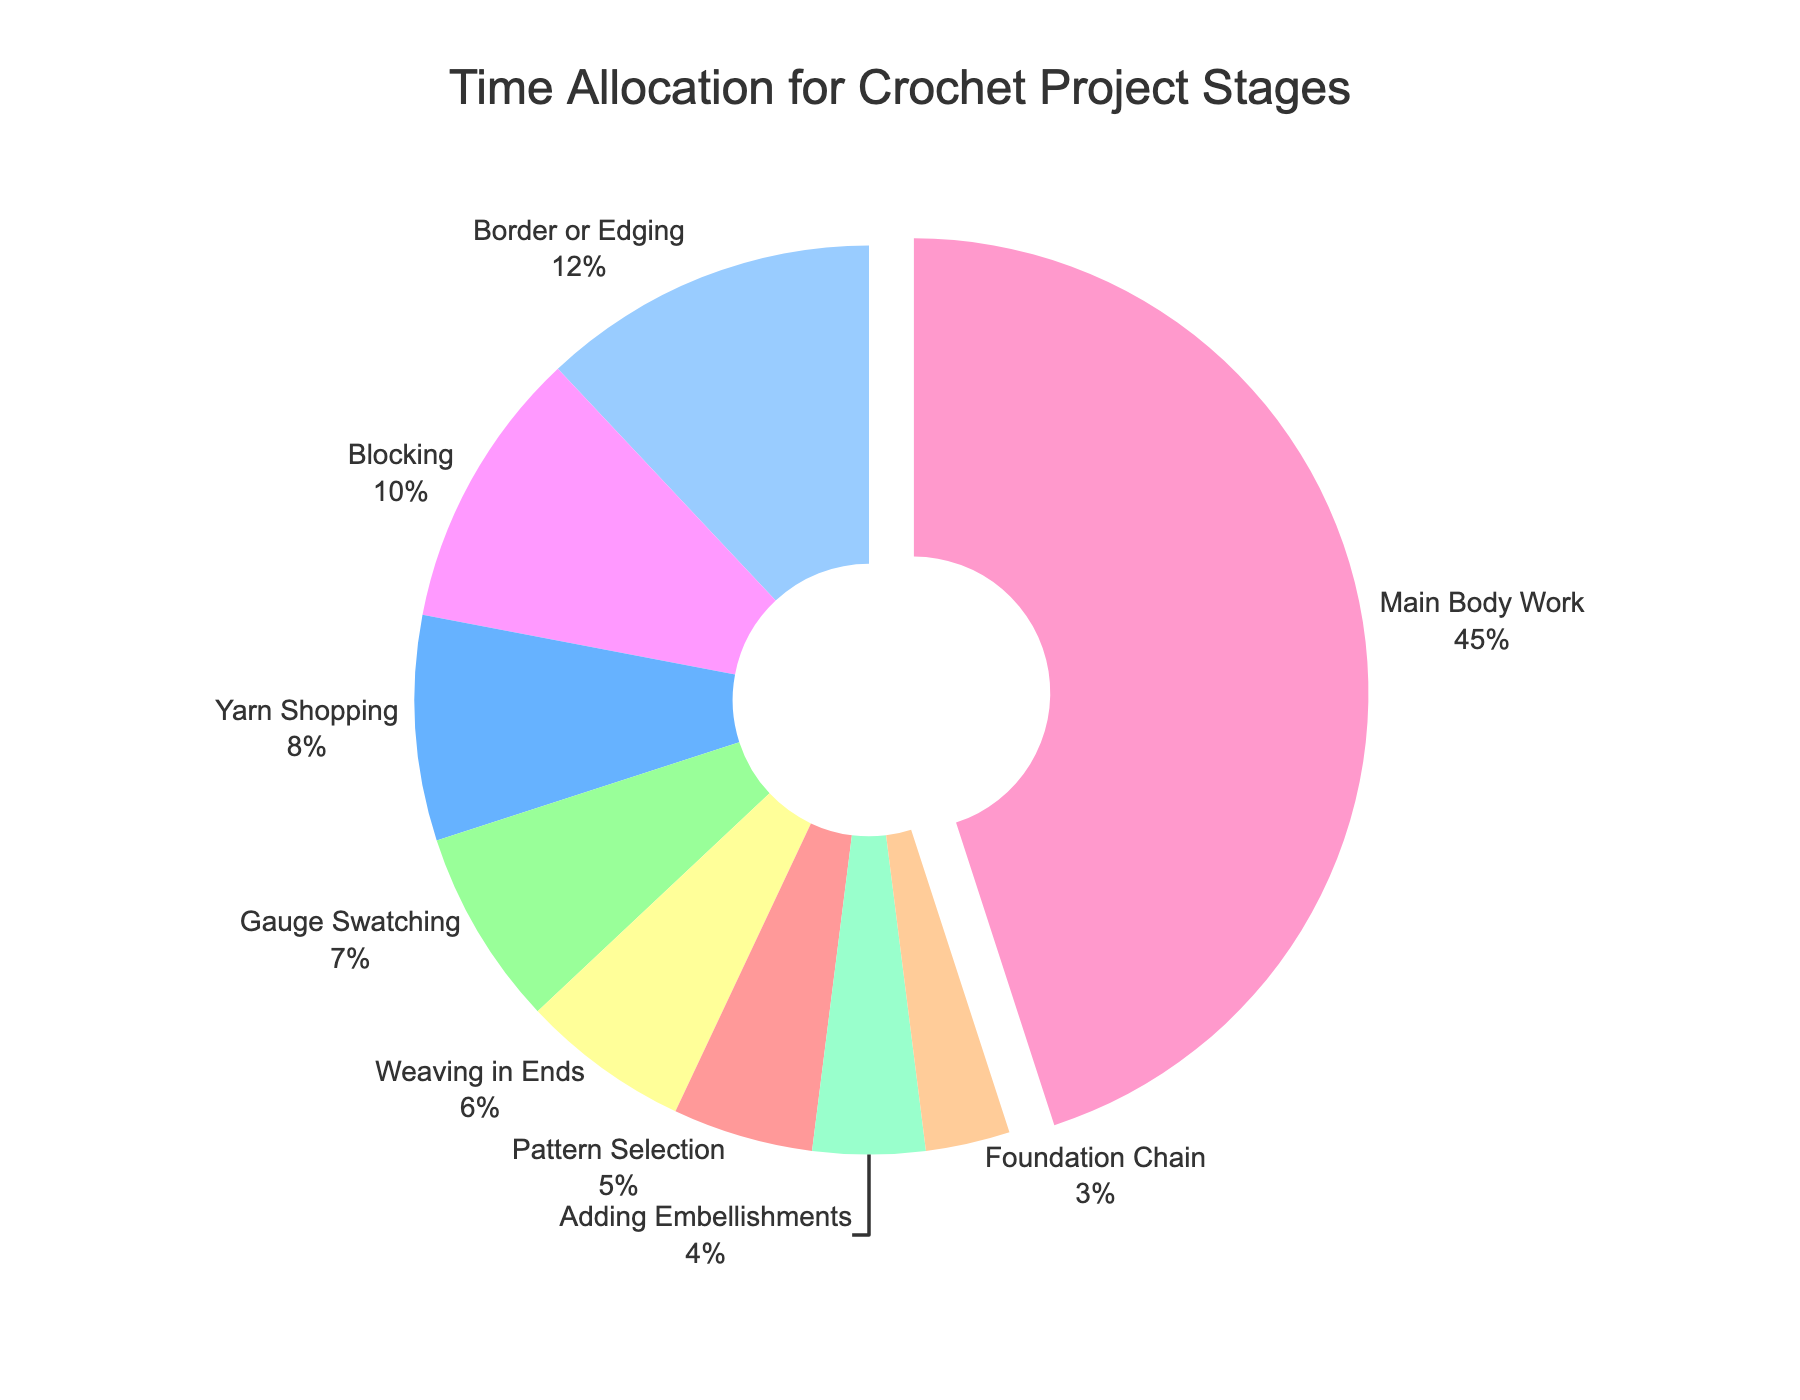What stage takes the most time in the crochet project? The section with the largest percentage is the "Main Body Work," which is visually pulled out from the pie due to the hole configuration. Its value is 45%.
Answer: Main Body Work What stages take up a combined 10% of the time? The two smallest sections are "Foundation Chain" (3%) and "Adding Embellishments" (4%). Their combined total is 3% + 4% = 7%, so we need to include another section, "Pattern Selection" (5%), to reach a value close to 10%. The exact combination can be validated as "Foundation Chain" (3%) + "Adding Embellishments" (4%) + part of "Pattern Selection" (5%).
Answer: Foundation Chain, Adding Embellishments, Pattern Selection (part) Which stages together make up more time than the Main Body Work? The main body work takes up 45%. Adding the times of the different stages until the total exceeds 45%: "Gauge Swatching" (7%), "Yarn Shopping" (8%), "Blocking" (10%), and "Border or Edging" (12%). The sum is 7% + 8% + 10% + 12% = 37%. Adding "Weaving in Ends" (6%) makes it 43%. Finally, adding "Pattern Selection" (5%), we get 43% + 5% = 48%, which exceeds 45%.
Answer: Gauge Swatching, Yarn Shopping, Blocking, Border or Edging, Weaving in Ends, Pattern Selection How much more time is spent on "Weaving in Ends" compared to the "Foundation Chain"? The "Weaving in Ends" stage is 6%, and the "Foundation Chain" stage is 3%. The difference between them is 6% - 3% = 3%.
Answer: 3% What is the total time allocation for non-main work stages combined? Summing all stages except "Main Body Work": "Pattern Selection" (5%), "Yarn Shopping" (8%), "Gauge Swatching" (7%), "Foundation Chain" (3%), "Border or Edging" (12%), "Weaving in Ends" (6%), "Blocking" (10%), "Adding Embellishments" (4%). The sum is 5% + 8% + 7% + 3% + 12% + 6% + 10% + 4% = 55%.
Answer: 55% What visual feature highlights the stage with the largest proportion in the pie chart? The largest segment, "Main Body Work," is visually pulled out from the pie chart, making it stand out.
Answer: Pulled out segment What stages represent the third and fourth largest time allocations, and how do their percentages compare? The third and fourth largest segments are "Blocking" (10%) and "Weaving in Ends" (6%). Comparing their percentages: 10% - 6% = 4%.
Answer: Blocking (10%), Weaving in Ends (6%); difference is 4% If we combine the time allocations for "Blocking" and "Border or Edging", what percentage do we get in total? Blocking takes 10%, and Border or Edging takes 12%. Adding these percentages gives 10% + 12% = 22%.
Answer: 22% Which stage has the smallest time allocation, and what is its percentage? The smallest stage in the pie chart is "Foundation Chain," with a percentage of 3%.
Answer: Foundation Chain, 3% How much less time is spent on "Gauge Swatching" compared to "Border or Edging"? "Gauge Swatching" takes 7%, and "Border or Edging" takes 12%. The difference is 12% - 7% = 5%.
Answer: 5% less 